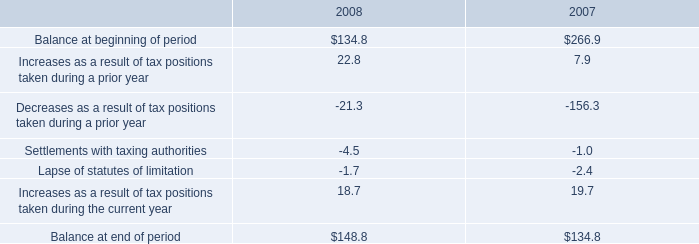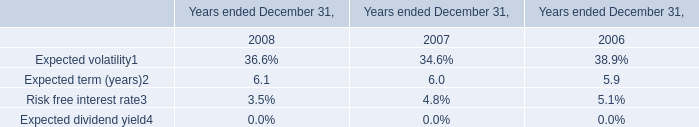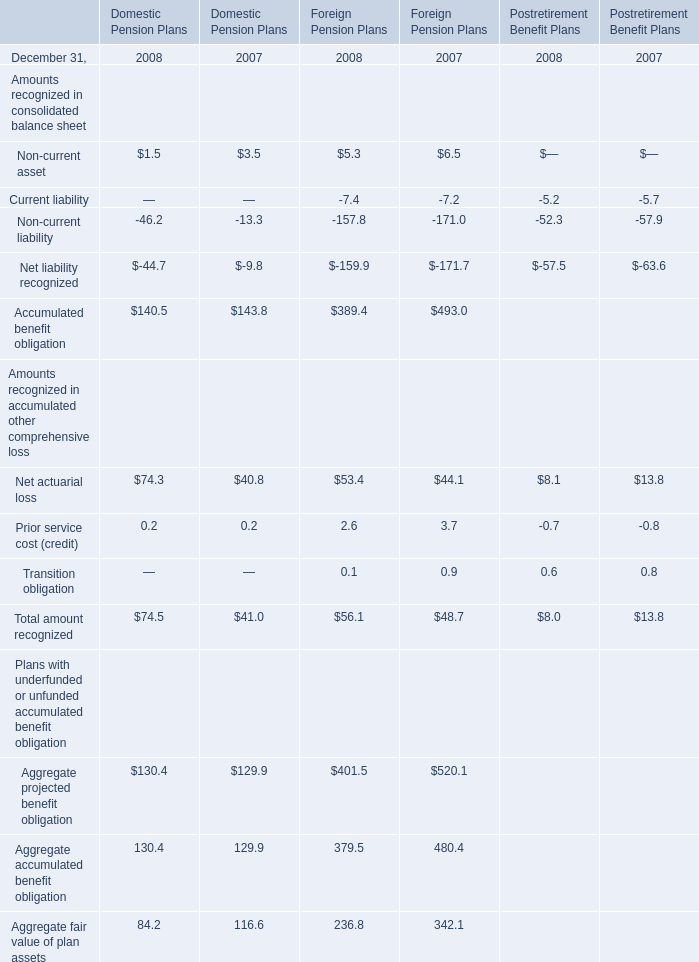what is the percentage increase from beginning to end of 2008 in unrecognized tax benefits? 
Computations: (((148.8 - 134.8) / 134.8) * 100)
Answer: 10.38576. 